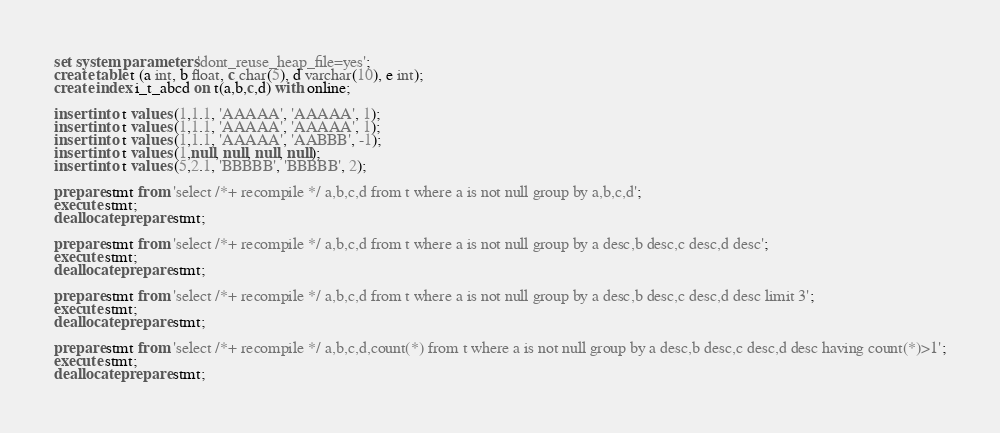<code> <loc_0><loc_0><loc_500><loc_500><_SQL_>set system parameters 'dont_reuse_heap_file=yes';
create table t (a int, b float, c char(5), d varchar(10), e int);
create index i_t_abcd on t(a,b,c,d) with online;

insert into t values (1,1.1, 'AAAAA', 'AAAAA', 1);
insert into t values (1,1.1, 'AAAAA', 'AAAAA', 1);
insert into t values (1,1.1, 'AAAAA', 'AABBB', -1);
insert into t values (1,null, null, null, null);
insert into t values (5,2.1, 'BBBBB', 'BBBBB', 2);

prepare stmt from 'select /*+ recompile */ a,b,c,d from t where a is not null group by a,b,c,d';
execute stmt;
deallocate prepare stmt;

prepare stmt from 'select /*+ recompile */ a,b,c,d from t where a is not null group by a desc,b desc,c desc,d desc';
execute stmt;
deallocate prepare stmt;

prepare stmt from 'select /*+ recompile */ a,b,c,d from t where a is not null group by a desc,b desc,c desc,d desc limit 3';
execute stmt;
deallocate prepare stmt;

prepare stmt from 'select /*+ recompile */ a,b,c,d,count(*) from t where a is not null group by a desc,b desc,c desc,d desc having count(*)>1';
execute stmt;
deallocate prepare stmt;
</code> 